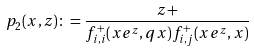Convert formula to latex. <formula><loc_0><loc_0><loc_500><loc_500>p _ { 2 } ( x , z ) \colon = \frac { z + } { f _ { i , i } ^ { + } ( x e ^ { z } , q x ) f _ { i , j } ^ { + } ( x e ^ { z } , x ) }</formula> 